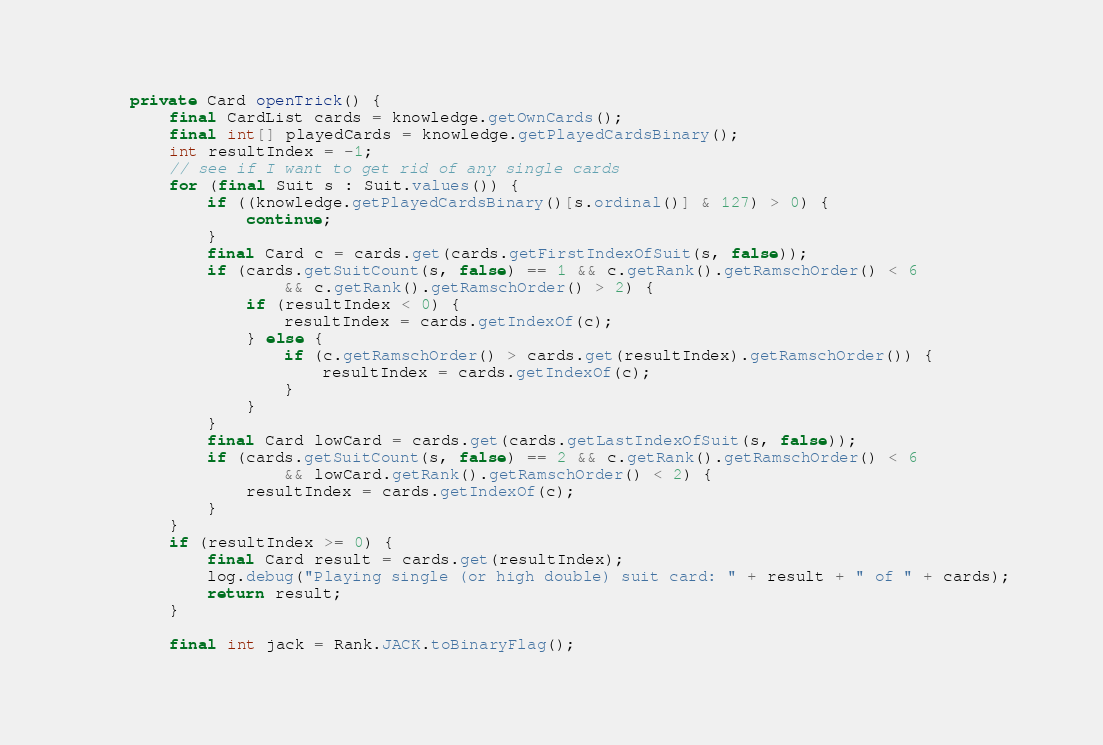Convert code to text. <code><loc_0><loc_0><loc_500><loc_500><_Java_>
	private Card openTrick() {
		final CardList cards = knowledge.getOwnCards();
		final int[] playedCards = knowledge.getPlayedCardsBinary();
		int resultIndex = -1;
		// see if I want to get rid of any single cards
		for (final Suit s : Suit.values()) {
			if ((knowledge.getPlayedCardsBinary()[s.ordinal()] & 127) > 0) {
				continue;
			}
			final Card c = cards.get(cards.getFirstIndexOfSuit(s, false));
			if (cards.getSuitCount(s, false) == 1 && c.getRank().getRamschOrder() < 6
					&& c.getRank().getRamschOrder() > 2) {
				if (resultIndex < 0) {
					resultIndex = cards.getIndexOf(c);
				} else {
					if (c.getRamschOrder() > cards.get(resultIndex).getRamschOrder()) {
						resultIndex = cards.getIndexOf(c);
					}
				}
			}
			final Card lowCard = cards.get(cards.getLastIndexOfSuit(s, false));
			if (cards.getSuitCount(s, false) == 2 && c.getRank().getRamschOrder() < 6
					&& lowCard.getRank().getRamschOrder() < 2) {
				resultIndex = cards.getIndexOf(c);
			}
		}
		if (resultIndex >= 0) {
			final Card result = cards.get(resultIndex);
			log.debug("Playing single (or high double) suit card: " + result + " of " + cards);
			return result;
		}

		final int jack = Rank.JACK.toBinaryFlag();</code> 